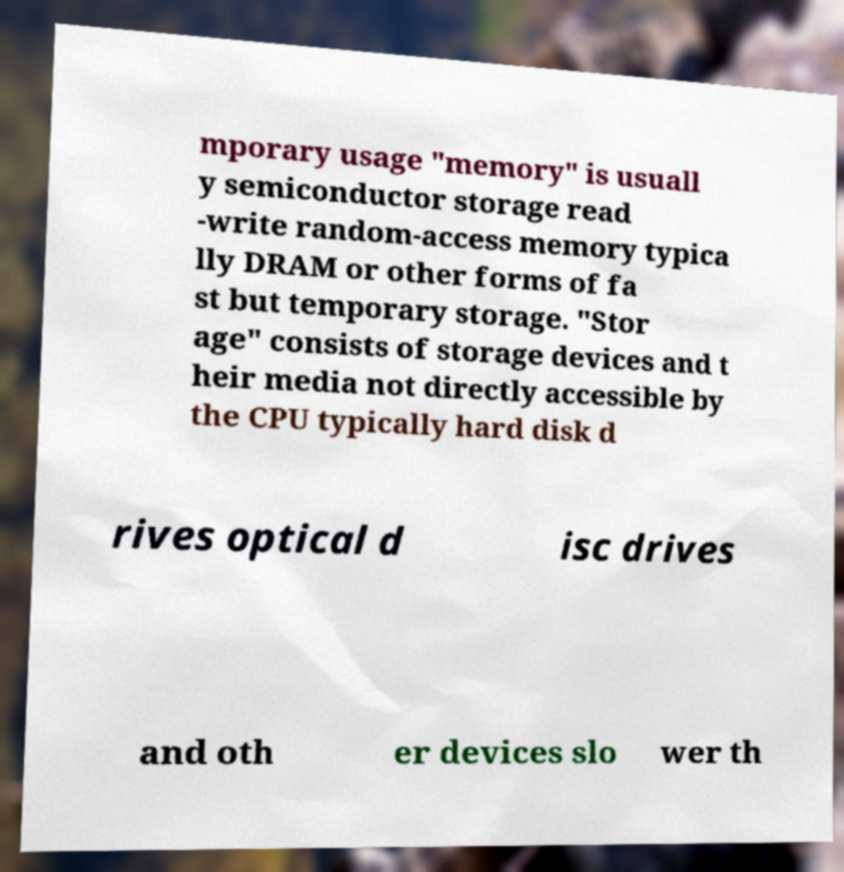For documentation purposes, I need the text within this image transcribed. Could you provide that? mporary usage "memory" is usuall y semiconductor storage read -write random-access memory typica lly DRAM or other forms of fa st but temporary storage. "Stor age" consists of storage devices and t heir media not directly accessible by the CPU typically hard disk d rives optical d isc drives and oth er devices slo wer th 